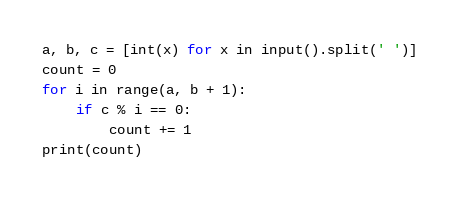Convert code to text. <code><loc_0><loc_0><loc_500><loc_500><_Python_>a, b, c = [int(x) for x in input().split(' ')]
count = 0
for i in range(a, b + 1):
    if c % i == 0:
        count += 1
print(count)
</code> 